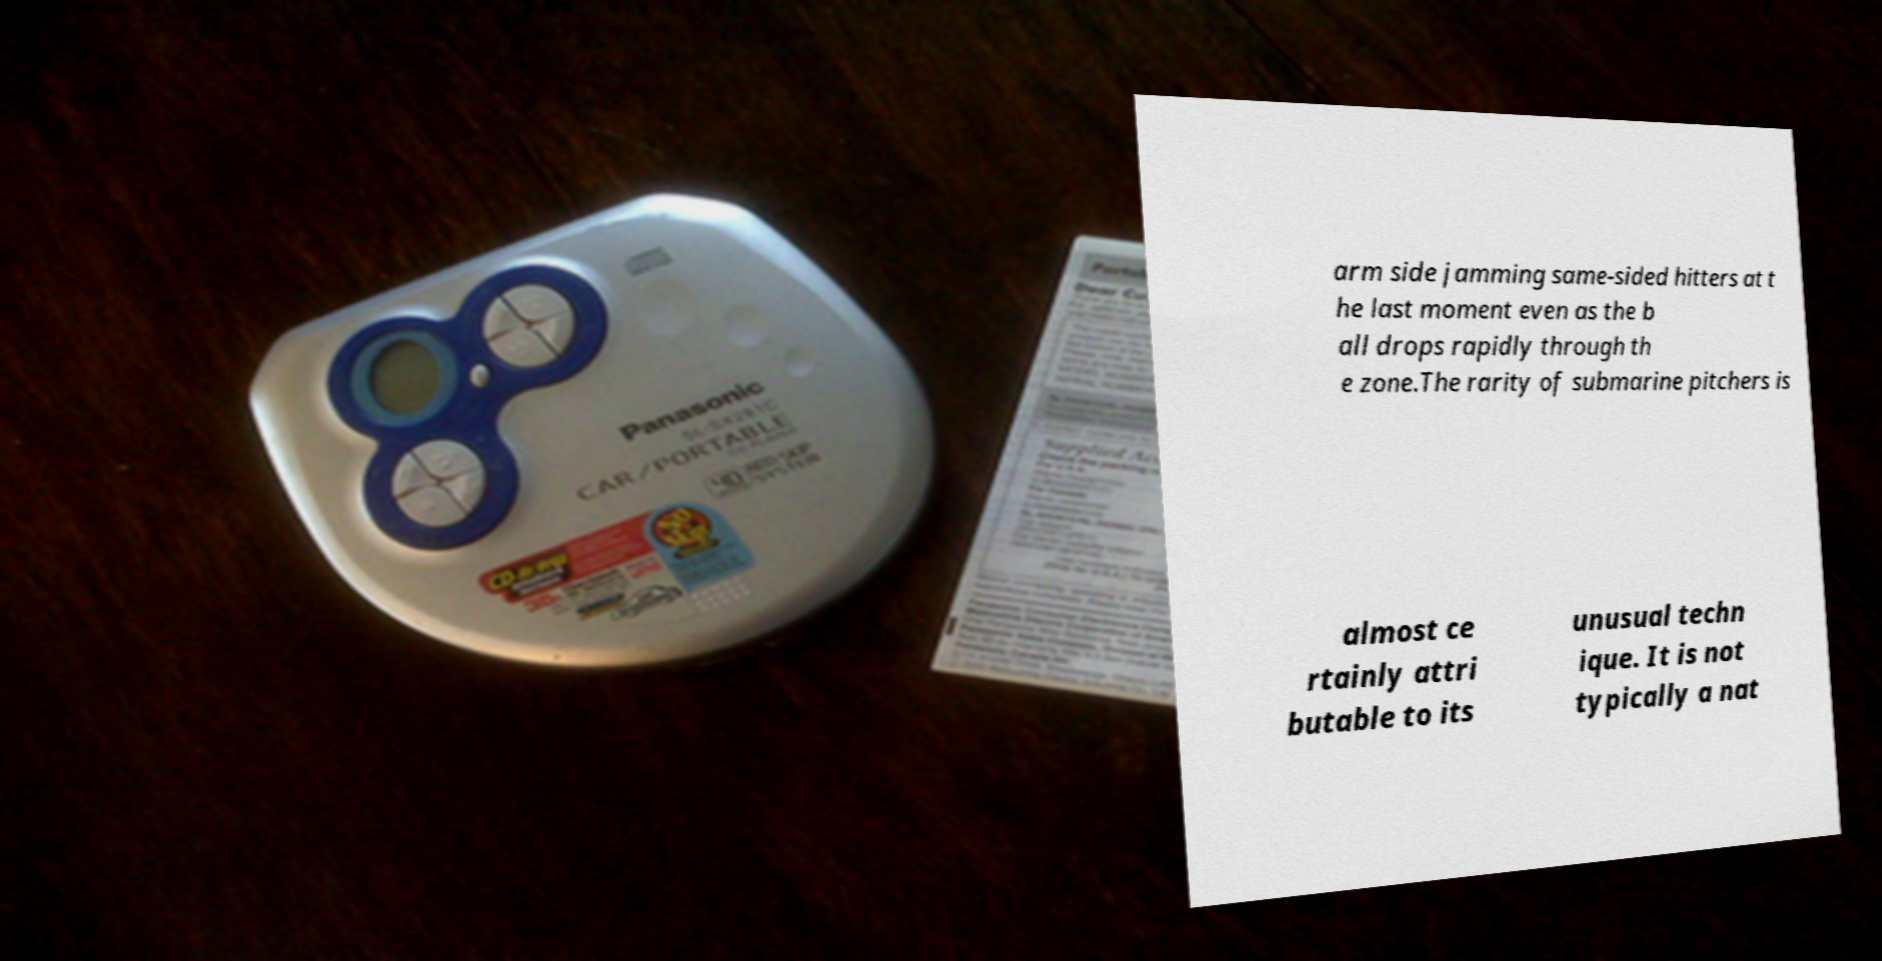What messages or text are displayed in this image? I need them in a readable, typed format. arm side jamming same-sided hitters at t he last moment even as the b all drops rapidly through th e zone.The rarity of submarine pitchers is almost ce rtainly attri butable to its unusual techn ique. It is not typically a nat 